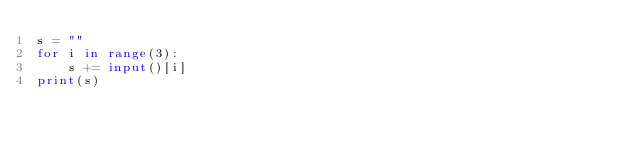Convert code to text. <code><loc_0><loc_0><loc_500><loc_500><_Python_>s = ""
for i in range(3):
    s += input()[i]
print(s)</code> 